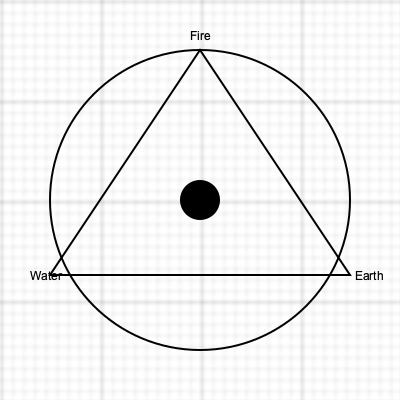In the magical system represented by the geometric symbols above, what would be the most likely effect of combining the "Void" element at the center with the triangular formation of Fire, Earth, and Water? To answer this question, we need to analyze the geometric symbolism and the elemental interactions:

1. The diagram shows a circle containing an equilateral triangle, with a smaller circle (Void) at the center.

2. The three vertices of the triangle represent Fire (top), Earth (bottom right), and Water (bottom left), forming a balanced triad of elemental forces.

3. The large circle encompassing the triangle suggests a holistic system or a cycle of energy.

4. The Void element at the center implies a neutral or nullifying force, potentially acting as a catalyst or amplifier for the other elements.

5. In many magical systems, combining opposing elements often results in powerful, unpredictable effects.

6. The triangular formation suggests a stable, balanced relationship between Fire, Earth, and Water.

7. Introducing the Void element to this balanced system would likely cause a disruption or transformation of the elemental energies.

8. Given the dark fantasy theme, this combination might result in a cataclysmic or reality-altering effect.

9. The most probable outcome would be a massive release of elemental energy, channeled and amplified by the Void, potentially creating a new form of matter or altering the fabric of reality itself.

Therefore, the most likely effect would be a reality-warping explosion of elemental energy.
Answer: Reality-warping elemental explosion 